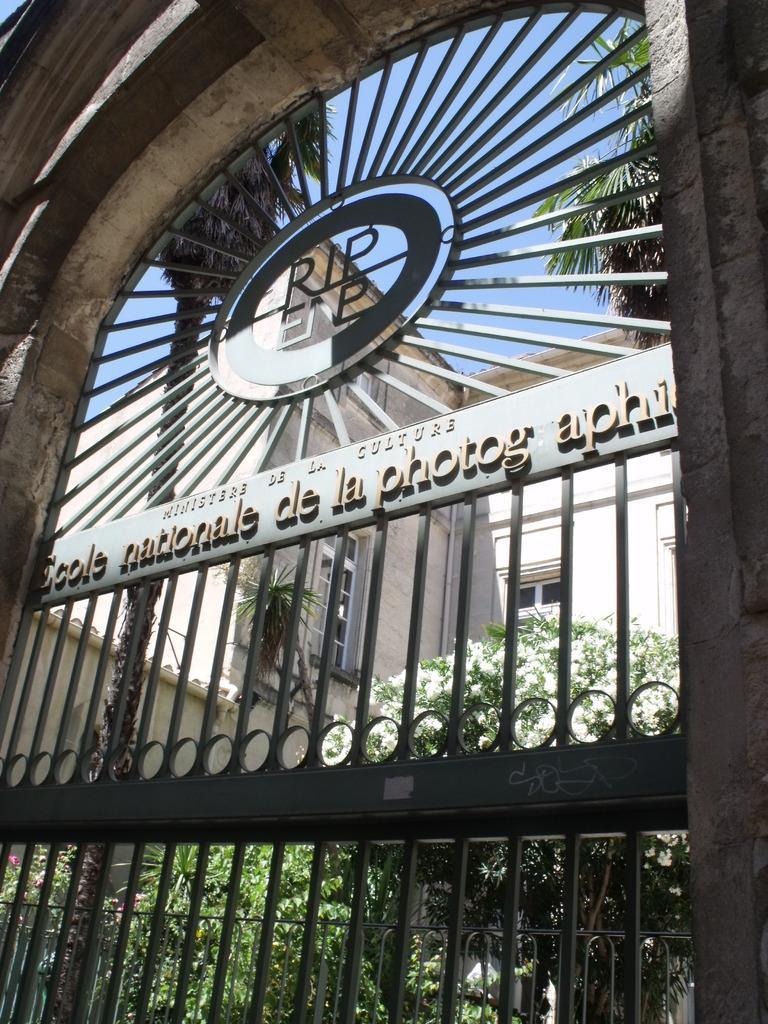Describe this image in one or two sentences. In this image we can see an arch with a railing. On that something is written. And there is an emblem. Through that we can see trees and building. Also there is sky. 